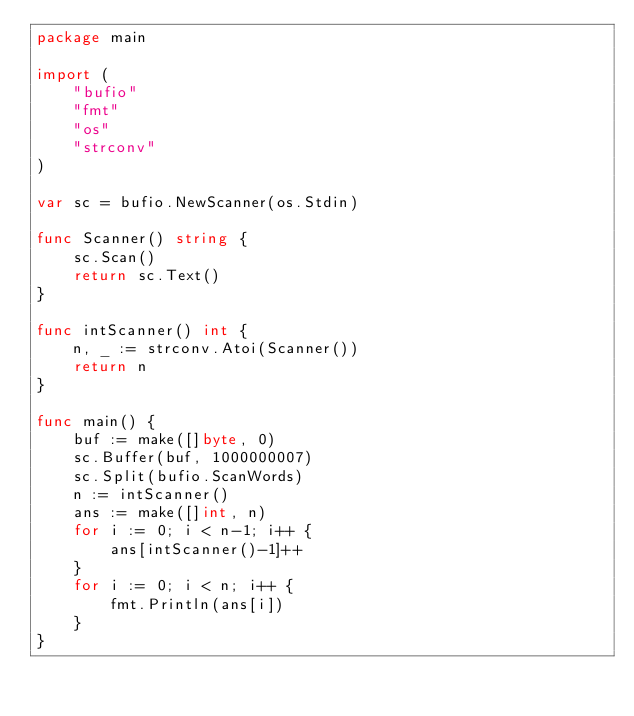Convert code to text. <code><loc_0><loc_0><loc_500><loc_500><_Go_>package main

import (
	"bufio"
	"fmt"
	"os"
	"strconv"
)

var sc = bufio.NewScanner(os.Stdin)

func Scanner() string {
	sc.Scan()
	return sc.Text()
}

func intScanner() int {
	n, _ := strconv.Atoi(Scanner())
	return n
}

func main() {
	buf := make([]byte, 0)
	sc.Buffer(buf, 1000000007)
	sc.Split(bufio.ScanWords)
	n := intScanner()
	ans := make([]int, n)
	for i := 0; i < n-1; i++ {
		ans[intScanner()-1]++
	}
	for i := 0; i < n; i++ {
		fmt.Println(ans[i])
	}
}
</code> 